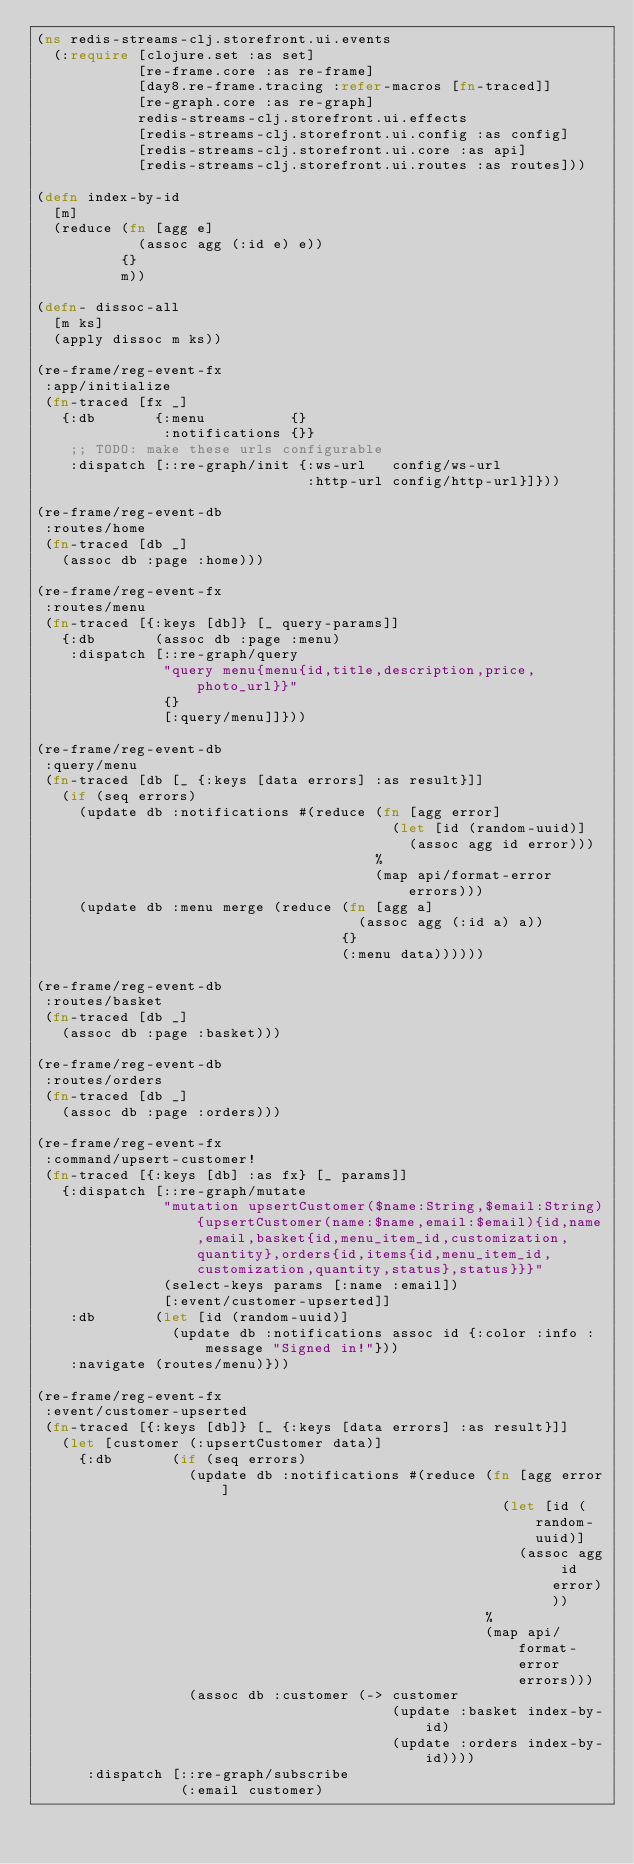<code> <loc_0><loc_0><loc_500><loc_500><_Clojure_>(ns redis-streams-clj.storefront.ui.events
  (:require [clojure.set :as set]
            [re-frame.core :as re-frame]
            [day8.re-frame.tracing :refer-macros [fn-traced]]
            [re-graph.core :as re-graph]
            redis-streams-clj.storefront.ui.effects
            [redis-streams-clj.storefront.ui.config :as config]
            [redis-streams-clj.storefront.ui.core :as api]
            [redis-streams-clj.storefront.ui.routes :as routes]))

(defn index-by-id
  [m]
  (reduce (fn [agg e]
            (assoc agg (:id e) e))
          {}
          m))

(defn- dissoc-all
  [m ks]
  (apply dissoc m ks))

(re-frame/reg-event-fx
 :app/initialize
 (fn-traced [fx _]
   {:db       {:menu          {}
               :notifications {}}
    ;; TODO: make these urls configurable
    :dispatch [::re-graph/init {:ws-url   config/ws-url
                                :http-url config/http-url}]}))

(re-frame/reg-event-db
 :routes/home
 (fn-traced [db _]
   (assoc db :page :home)))

(re-frame/reg-event-fx
 :routes/menu
 (fn-traced [{:keys [db]} [_ query-params]]
   {:db       (assoc db :page :menu)
    :dispatch [::re-graph/query
               "query menu{menu{id,title,description,price,photo_url}}"
               {}
               [:query/menu]]}))

(re-frame/reg-event-db
 :query/menu
 (fn-traced [db [_ {:keys [data errors] :as result}]]
   (if (seq errors)
     (update db :notifications #(reduce (fn [agg error]
                                          (let [id (random-uuid)]
                                            (assoc agg id error)))
                                        %
                                        (map api/format-error errors)))
     (update db :menu merge (reduce (fn [agg a]
                                      (assoc agg (:id a) a))
                                    {}
                                    (:menu data))))))

(re-frame/reg-event-db
 :routes/basket
 (fn-traced [db _]
   (assoc db :page :basket)))

(re-frame/reg-event-db
 :routes/orders
 (fn-traced [db _]
   (assoc db :page :orders)))

(re-frame/reg-event-fx
 :command/upsert-customer!
 (fn-traced [{:keys [db] :as fx} [_ params]]
   {:dispatch [::re-graph/mutate
               "mutation upsertCustomer($name:String,$email:String){upsertCustomer(name:$name,email:$email){id,name,email,basket{id,menu_item_id,customization,quantity},orders{id,items{id,menu_item_id,customization,quantity,status},status}}}"
               (select-keys params [:name :email])
               [:event/customer-upserted]]
    :db       (let [id (random-uuid)]
                (update db :notifications assoc id {:color :info :message "Signed in!"}))
    :navigate (routes/menu)}))

(re-frame/reg-event-fx
 :event/customer-upserted
 (fn-traced [{:keys [db]} [_ {:keys [data errors] :as result}]]
   (let [customer (:upsertCustomer data)]
     {:db       (if (seq errors)
                  (update db :notifications #(reduce (fn [agg error]
                                                       (let [id (random-uuid)]
                                                         (assoc agg id error)))
                                                     %
                                                     (map api/format-error errors)))
                  (assoc db :customer (-> customer
                                          (update :basket index-by-id)
                                          (update :orders index-by-id))))
      :dispatch [::re-graph/subscribe
                 (:email customer)</code> 